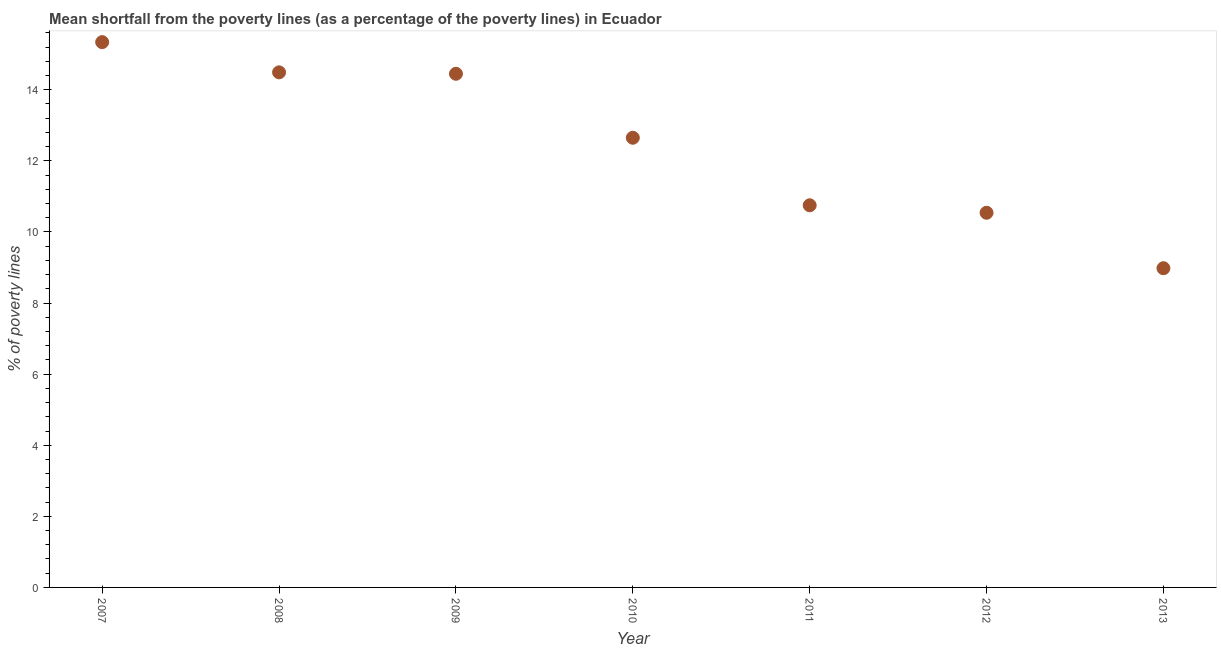What is the poverty gap at national poverty lines in 2010?
Give a very brief answer. 12.65. Across all years, what is the maximum poverty gap at national poverty lines?
Your answer should be compact. 15.34. Across all years, what is the minimum poverty gap at national poverty lines?
Make the answer very short. 8.98. In which year was the poverty gap at national poverty lines maximum?
Provide a succinct answer. 2007. In which year was the poverty gap at national poverty lines minimum?
Provide a succinct answer. 2013. What is the sum of the poverty gap at national poverty lines?
Keep it short and to the point. 87.2. What is the difference between the poverty gap at national poverty lines in 2007 and 2013?
Provide a succinct answer. 6.36. What is the average poverty gap at national poverty lines per year?
Your response must be concise. 12.46. What is the median poverty gap at national poverty lines?
Offer a terse response. 12.65. In how many years, is the poverty gap at national poverty lines greater than 9.6 %?
Your answer should be compact. 6. Do a majority of the years between 2012 and 2008 (inclusive) have poverty gap at national poverty lines greater than 8 %?
Provide a short and direct response. Yes. What is the ratio of the poverty gap at national poverty lines in 2011 to that in 2013?
Provide a succinct answer. 1.2. Is the poverty gap at national poverty lines in 2009 less than that in 2010?
Your response must be concise. No. Is the difference between the poverty gap at national poverty lines in 2009 and 2010 greater than the difference between any two years?
Make the answer very short. No. What is the difference between the highest and the second highest poverty gap at national poverty lines?
Make the answer very short. 0.85. What is the difference between the highest and the lowest poverty gap at national poverty lines?
Provide a short and direct response. 6.36. How many dotlines are there?
Your response must be concise. 1. What is the difference between two consecutive major ticks on the Y-axis?
Offer a terse response. 2. Are the values on the major ticks of Y-axis written in scientific E-notation?
Offer a terse response. No. Does the graph contain grids?
Ensure brevity in your answer.  No. What is the title of the graph?
Provide a succinct answer. Mean shortfall from the poverty lines (as a percentage of the poverty lines) in Ecuador. What is the label or title of the Y-axis?
Provide a succinct answer. % of poverty lines. What is the % of poverty lines in 2007?
Make the answer very short. 15.34. What is the % of poverty lines in 2008?
Provide a succinct answer. 14.49. What is the % of poverty lines in 2009?
Provide a short and direct response. 14.45. What is the % of poverty lines in 2010?
Give a very brief answer. 12.65. What is the % of poverty lines in 2011?
Make the answer very short. 10.75. What is the % of poverty lines in 2012?
Make the answer very short. 10.54. What is the % of poverty lines in 2013?
Your answer should be compact. 8.98. What is the difference between the % of poverty lines in 2007 and 2009?
Ensure brevity in your answer.  0.89. What is the difference between the % of poverty lines in 2007 and 2010?
Provide a succinct answer. 2.69. What is the difference between the % of poverty lines in 2007 and 2011?
Your answer should be very brief. 4.59. What is the difference between the % of poverty lines in 2007 and 2012?
Your answer should be compact. 4.8. What is the difference between the % of poverty lines in 2007 and 2013?
Keep it short and to the point. 6.36. What is the difference between the % of poverty lines in 2008 and 2010?
Make the answer very short. 1.84. What is the difference between the % of poverty lines in 2008 and 2011?
Your response must be concise. 3.74. What is the difference between the % of poverty lines in 2008 and 2012?
Your answer should be compact. 3.95. What is the difference between the % of poverty lines in 2008 and 2013?
Your answer should be very brief. 5.51. What is the difference between the % of poverty lines in 2009 and 2010?
Make the answer very short. 1.8. What is the difference between the % of poverty lines in 2009 and 2011?
Your response must be concise. 3.7. What is the difference between the % of poverty lines in 2009 and 2012?
Your answer should be very brief. 3.91. What is the difference between the % of poverty lines in 2009 and 2013?
Provide a succinct answer. 5.47. What is the difference between the % of poverty lines in 2010 and 2011?
Give a very brief answer. 1.9. What is the difference between the % of poverty lines in 2010 and 2012?
Give a very brief answer. 2.11. What is the difference between the % of poverty lines in 2010 and 2013?
Provide a short and direct response. 3.67. What is the difference between the % of poverty lines in 2011 and 2012?
Give a very brief answer. 0.21. What is the difference between the % of poverty lines in 2011 and 2013?
Your answer should be compact. 1.77. What is the difference between the % of poverty lines in 2012 and 2013?
Ensure brevity in your answer.  1.56. What is the ratio of the % of poverty lines in 2007 to that in 2008?
Provide a succinct answer. 1.06. What is the ratio of the % of poverty lines in 2007 to that in 2009?
Ensure brevity in your answer.  1.06. What is the ratio of the % of poverty lines in 2007 to that in 2010?
Your response must be concise. 1.21. What is the ratio of the % of poverty lines in 2007 to that in 2011?
Offer a very short reply. 1.43. What is the ratio of the % of poverty lines in 2007 to that in 2012?
Keep it short and to the point. 1.46. What is the ratio of the % of poverty lines in 2007 to that in 2013?
Offer a very short reply. 1.71. What is the ratio of the % of poverty lines in 2008 to that in 2009?
Offer a terse response. 1. What is the ratio of the % of poverty lines in 2008 to that in 2010?
Give a very brief answer. 1.15. What is the ratio of the % of poverty lines in 2008 to that in 2011?
Your answer should be very brief. 1.35. What is the ratio of the % of poverty lines in 2008 to that in 2012?
Make the answer very short. 1.38. What is the ratio of the % of poverty lines in 2008 to that in 2013?
Make the answer very short. 1.61. What is the ratio of the % of poverty lines in 2009 to that in 2010?
Your answer should be compact. 1.14. What is the ratio of the % of poverty lines in 2009 to that in 2011?
Your answer should be compact. 1.34. What is the ratio of the % of poverty lines in 2009 to that in 2012?
Your response must be concise. 1.37. What is the ratio of the % of poverty lines in 2009 to that in 2013?
Give a very brief answer. 1.61. What is the ratio of the % of poverty lines in 2010 to that in 2011?
Your response must be concise. 1.18. What is the ratio of the % of poverty lines in 2010 to that in 2012?
Make the answer very short. 1.2. What is the ratio of the % of poverty lines in 2010 to that in 2013?
Your answer should be compact. 1.41. What is the ratio of the % of poverty lines in 2011 to that in 2013?
Give a very brief answer. 1.2. What is the ratio of the % of poverty lines in 2012 to that in 2013?
Your response must be concise. 1.17. 